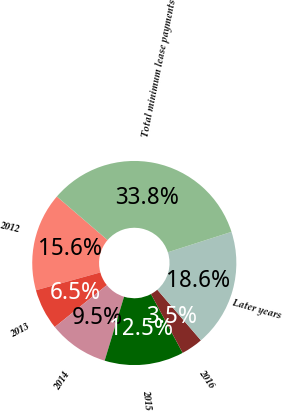Convert chart to OTSL. <chart><loc_0><loc_0><loc_500><loc_500><pie_chart><fcel>2012<fcel>2013<fcel>2014<fcel>2015<fcel>2016<fcel>Later years<fcel>Total minimum lease payments<nl><fcel>15.59%<fcel>6.49%<fcel>9.52%<fcel>12.55%<fcel>3.46%<fcel>18.62%<fcel>33.78%<nl></chart> 